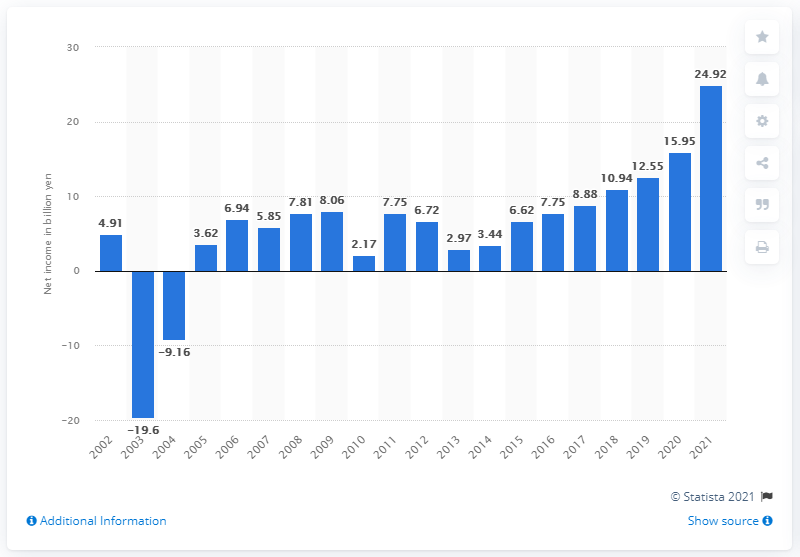Draw attention to some important aspects in this diagram. In the previous fiscal year, Capcom's net income was 15,950,000. In March 2021, Capcom's net income was 24.92. 